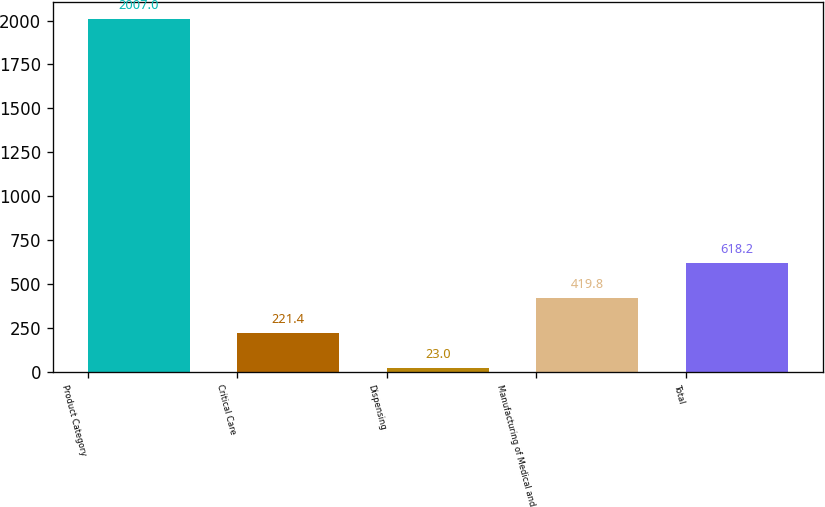<chart> <loc_0><loc_0><loc_500><loc_500><bar_chart><fcel>Product Category<fcel>Critical Care<fcel>Dispensing<fcel>Manufacturing of Medical and<fcel>Total<nl><fcel>2007<fcel>221.4<fcel>23<fcel>419.8<fcel>618.2<nl></chart> 